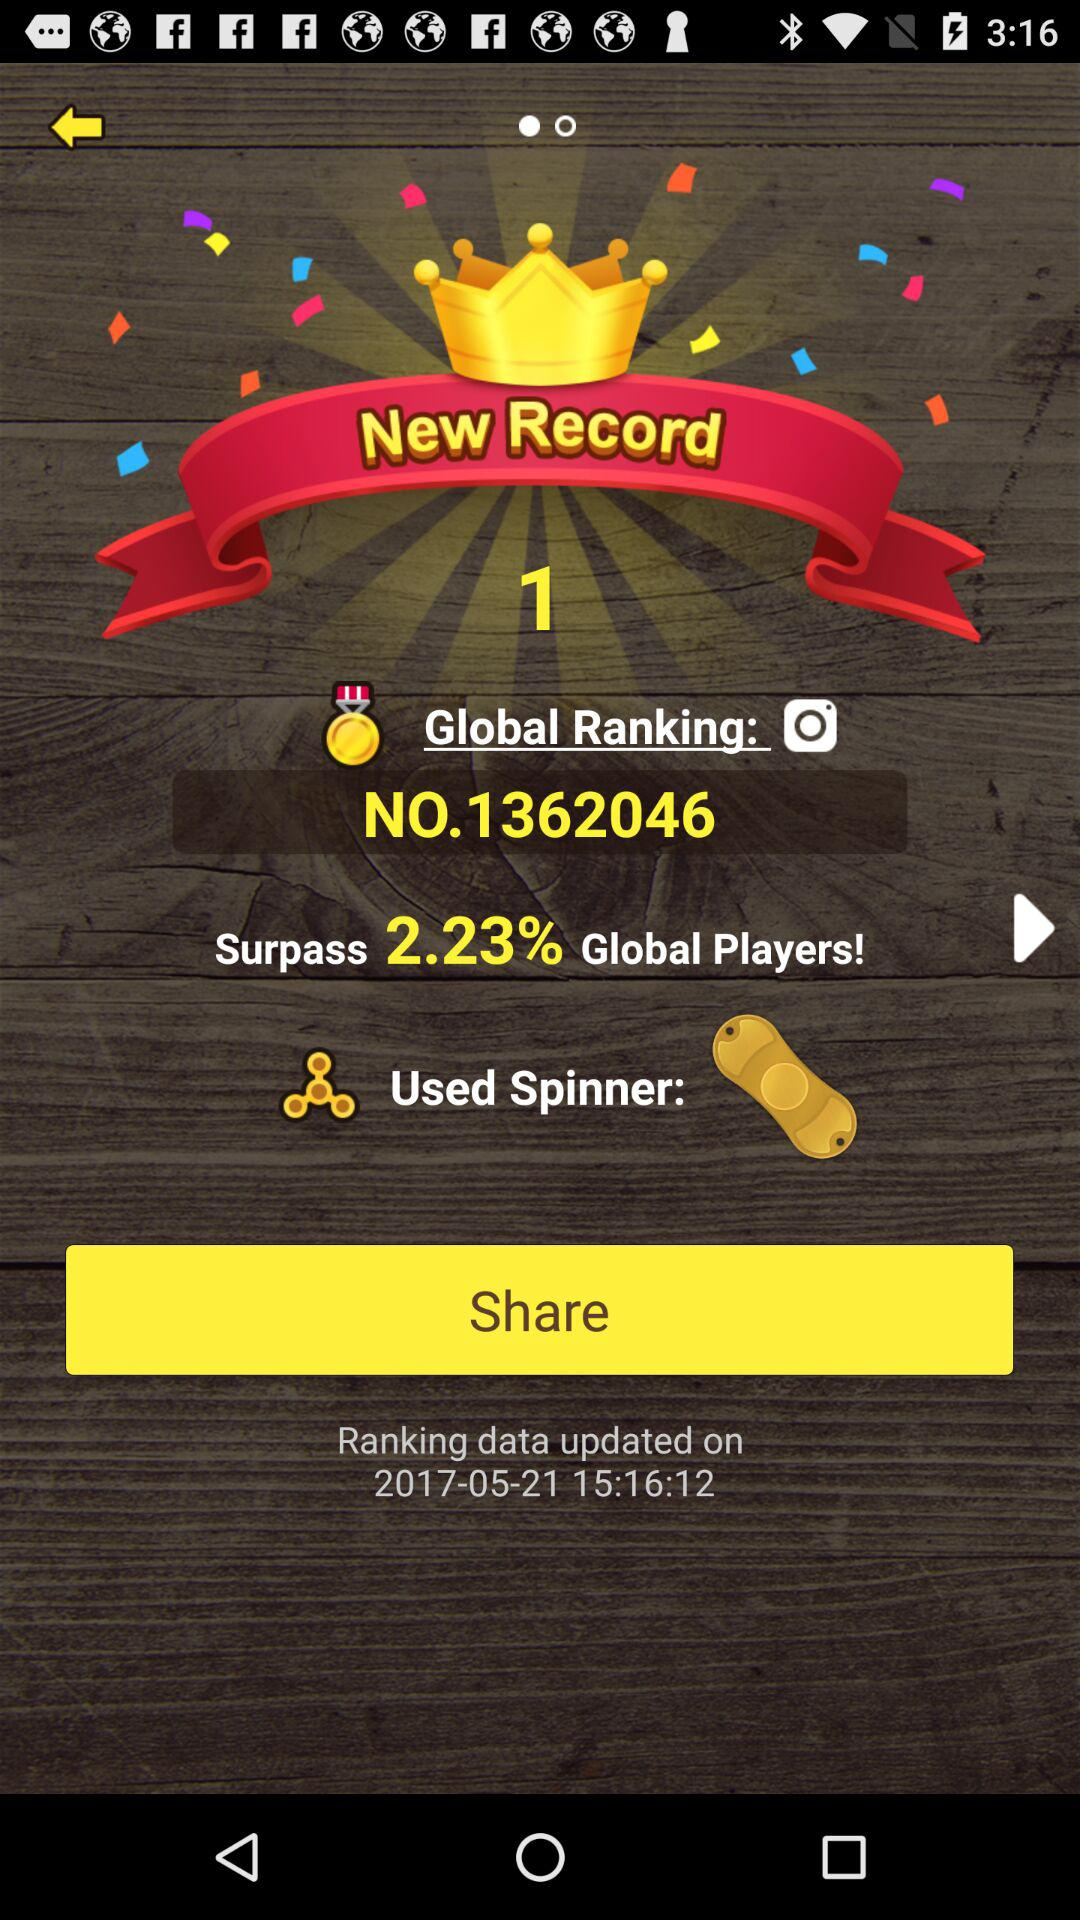What is the global ranking? The global ranking is 1362046. 